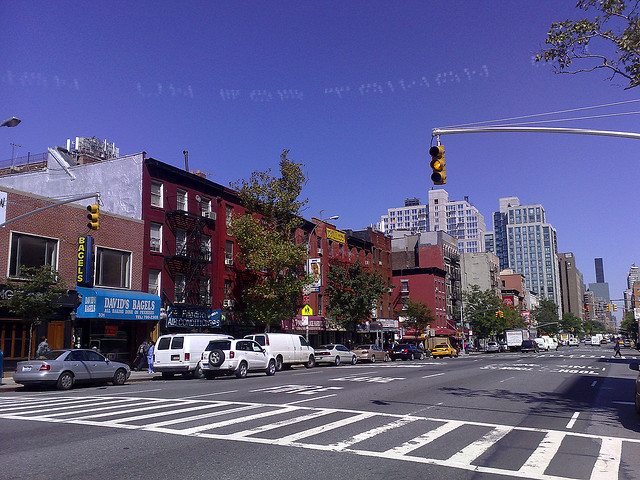<image>At what time did the traffic change from green to yellow? It is unknown at what time the traffic changed from green to yellow. No time is given in the image. At what time did the traffic change from green to yellow? I don't know at what time the traffic changed from green to yellow. There is no specific time given. 